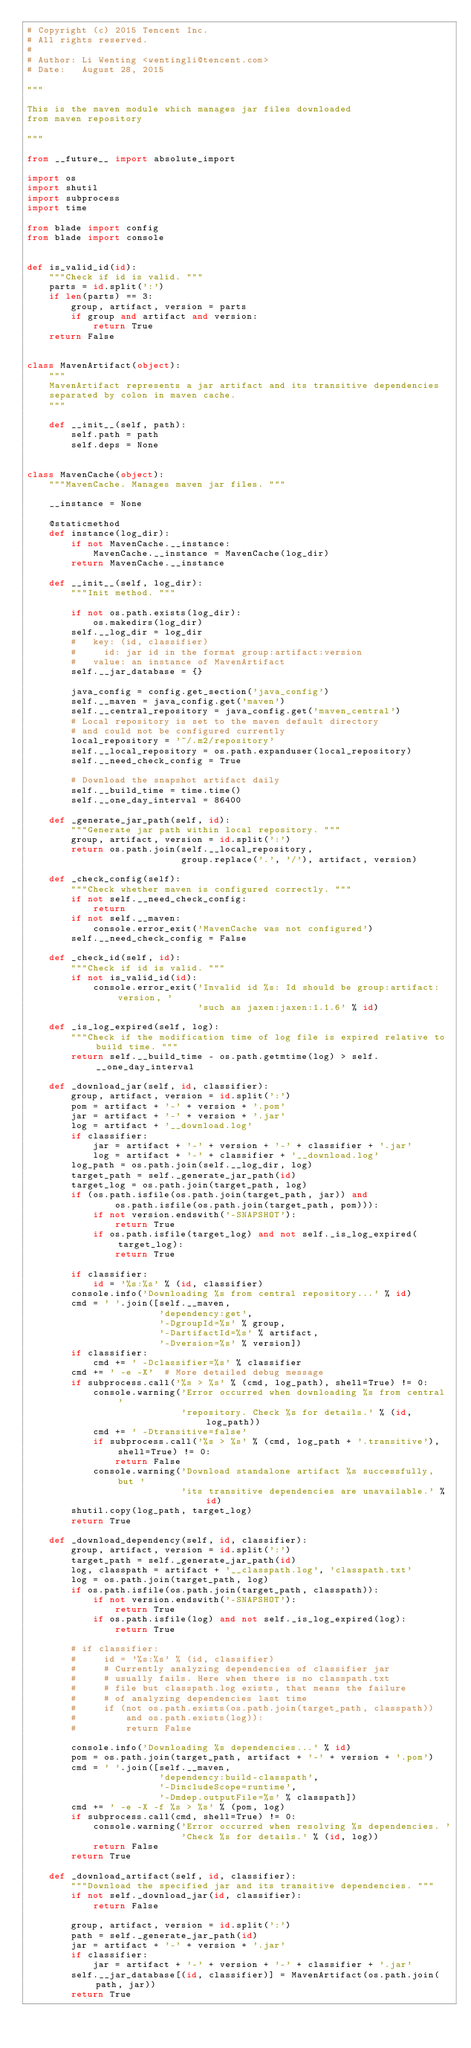Convert code to text. <code><loc_0><loc_0><loc_500><loc_500><_Python_># Copyright (c) 2015 Tencent Inc.
# All rights reserved.
#
# Author: Li Wenting <wentingli@tencent.com>
# Date:   August 28, 2015

"""

This is the maven module which manages jar files downloaded
from maven repository

"""

from __future__ import absolute_import

import os
import shutil
import subprocess
import time

from blade import config
from blade import console


def is_valid_id(id):
    """Check if id is valid. """
    parts = id.split(':')
    if len(parts) == 3:
        group, artifact, version = parts
        if group and artifact and version:
            return True
    return False


class MavenArtifact(object):
    """
    MavenArtifact represents a jar artifact and its transitive dependencies
    separated by colon in maven cache.
    """

    def __init__(self, path):
        self.path = path
        self.deps = None


class MavenCache(object):
    """MavenCache. Manages maven jar files. """

    __instance = None

    @staticmethod
    def instance(log_dir):
        if not MavenCache.__instance:
            MavenCache.__instance = MavenCache(log_dir)
        return MavenCache.__instance

    def __init__(self, log_dir):
        """Init method. """

        if not os.path.exists(log_dir):
            os.makedirs(log_dir)
        self.__log_dir = log_dir
        #   key: (id, classifier)
        #     id: jar id in the format group:artifact:version
        #   value: an instance of MavenArtifact
        self.__jar_database = {}

        java_config = config.get_section('java_config')
        self.__maven = java_config.get('maven')
        self.__central_repository = java_config.get('maven_central')
        # Local repository is set to the maven default directory
        # and could not be configured currently
        local_repository = '~/.m2/repository'
        self.__local_repository = os.path.expanduser(local_repository)
        self.__need_check_config = True

        # Download the snapshot artifact daily
        self.__build_time = time.time()
        self.__one_day_interval = 86400

    def _generate_jar_path(self, id):
        """Generate jar path within local repository. """
        group, artifact, version = id.split(':')
        return os.path.join(self.__local_repository,
                            group.replace('.', '/'), artifact, version)

    def _check_config(self):
        """Check whether maven is configured correctly. """
        if not self.__need_check_config:
            return
        if not self.__maven:
            console.error_exit('MavenCache was not configured')
        self.__need_check_config = False

    def _check_id(self, id):
        """Check if id is valid. """
        if not is_valid_id(id):
            console.error_exit('Invalid id %s: Id should be group:artifact:version, '
                               'such as jaxen:jaxen:1.1.6' % id)

    def _is_log_expired(self, log):
        """Check if the modification time of log file is expired relative to build time. """
        return self.__build_time - os.path.getmtime(log) > self.__one_day_interval

    def _download_jar(self, id, classifier):
        group, artifact, version = id.split(':')
        pom = artifact + '-' + version + '.pom'
        jar = artifact + '-' + version + '.jar'
        log = artifact + '__download.log'
        if classifier:
            jar = artifact + '-' + version + '-' + classifier + '.jar'
            log = artifact + '-' + classifier + '__download.log'
        log_path = os.path.join(self.__log_dir, log)
        target_path = self._generate_jar_path(id)
        target_log = os.path.join(target_path, log)
        if (os.path.isfile(os.path.join(target_path, jar)) and
                os.path.isfile(os.path.join(target_path, pom))):
            if not version.endswith('-SNAPSHOT'):
                return True
            if os.path.isfile(target_log) and not self._is_log_expired(target_log):
                return True

        if classifier:
            id = '%s:%s' % (id, classifier)
        console.info('Downloading %s from central repository...' % id)
        cmd = ' '.join([self.__maven,
                        'dependency:get',
                        '-DgroupId=%s' % group,
                        '-DartifactId=%s' % artifact,
                        '-Dversion=%s' % version])
        if classifier:
            cmd += ' -Dclassifier=%s' % classifier
        cmd += ' -e -X'  # More detailed debug message
        if subprocess.call('%s > %s' % (cmd, log_path), shell=True) != 0:
            console.warning('Error occurred when downloading %s from central '
                            'repository. Check %s for details.' % (id, log_path))
            cmd += ' -Dtransitive=false'
            if subprocess.call('%s > %s' % (cmd, log_path + '.transitive'), shell=True) != 0:
                return False
            console.warning('Download standalone artifact %s successfully, but '
                            'its transitive dependencies are unavailable.' % id)
        shutil.copy(log_path, target_log)
        return True

    def _download_dependency(self, id, classifier):
        group, artifact, version = id.split(':')
        target_path = self._generate_jar_path(id)
        log, classpath = artifact + '__classpath.log', 'classpath.txt'
        log = os.path.join(target_path, log)
        if os.path.isfile(os.path.join(target_path, classpath)):
            if not version.endswith('-SNAPSHOT'):
                return True
            if os.path.isfile(log) and not self._is_log_expired(log):
                return True

        # if classifier:
        #     id = '%s:%s' % (id, classifier)
        #     # Currently analyzing dependencies of classifier jar
        #     # usually fails. Here when there is no classpath.txt
        #     # file but classpath.log exists, that means the failure
        #     # of analyzing dependencies last time
        #     if (not os.path.exists(os.path.join(target_path, classpath))
        #         and os.path.exists(log)):
        #         return False

        console.info('Downloading %s dependencies...' % id)
        pom = os.path.join(target_path, artifact + '-' + version + '.pom')
        cmd = ' '.join([self.__maven,
                        'dependency:build-classpath',
                        '-DincludeScope=runtime',
                        '-Dmdep.outputFile=%s' % classpath])
        cmd += ' -e -X -f %s > %s' % (pom, log)
        if subprocess.call(cmd, shell=True) != 0:
            console.warning('Error occurred when resolving %s dependencies. '
                            'Check %s for details.' % (id, log))
            return False
        return True

    def _download_artifact(self, id, classifier):
        """Download the specified jar and its transitive dependencies. """
        if not self._download_jar(id, classifier):
            return False

        group, artifact, version = id.split(':')
        path = self._generate_jar_path(id)
        jar = artifact + '-' + version + '.jar'
        if classifier:
            jar = artifact + '-' + version + '-' + classifier + '.jar'
        self.__jar_database[(id, classifier)] = MavenArtifact(os.path.join(path, jar))
        return True
</code> 